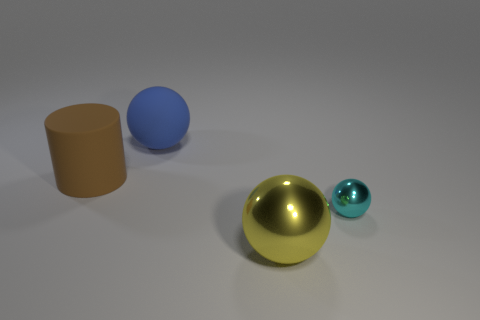Add 1 red cylinders. How many objects exist? 5 Subtract all balls. How many objects are left? 1 Subtract all big brown matte objects. Subtract all yellow metallic balls. How many objects are left? 2 Add 3 cyan objects. How many cyan objects are left? 4 Add 3 small balls. How many small balls exist? 4 Subtract 0 green cubes. How many objects are left? 4 